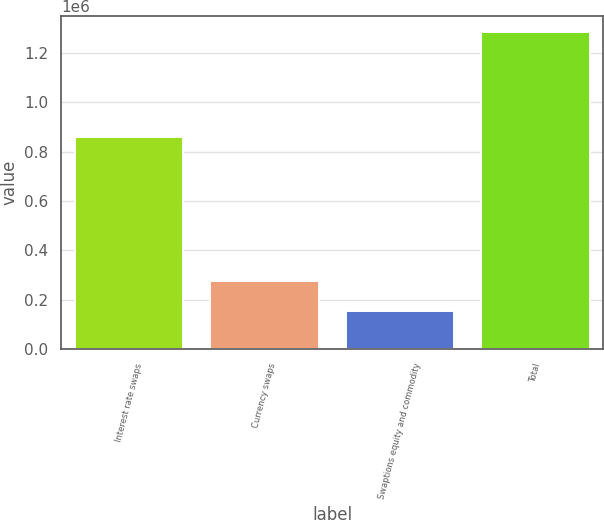Convert chart. <chart><loc_0><loc_0><loc_500><loc_500><bar_chart><fcel>Interest rate swaps<fcel>Currency swaps<fcel>Swaptions equity and commodity<fcel>Total<nl><fcel>858733<fcel>275466<fcel>151789<fcel>1.28599e+06<nl></chart> 